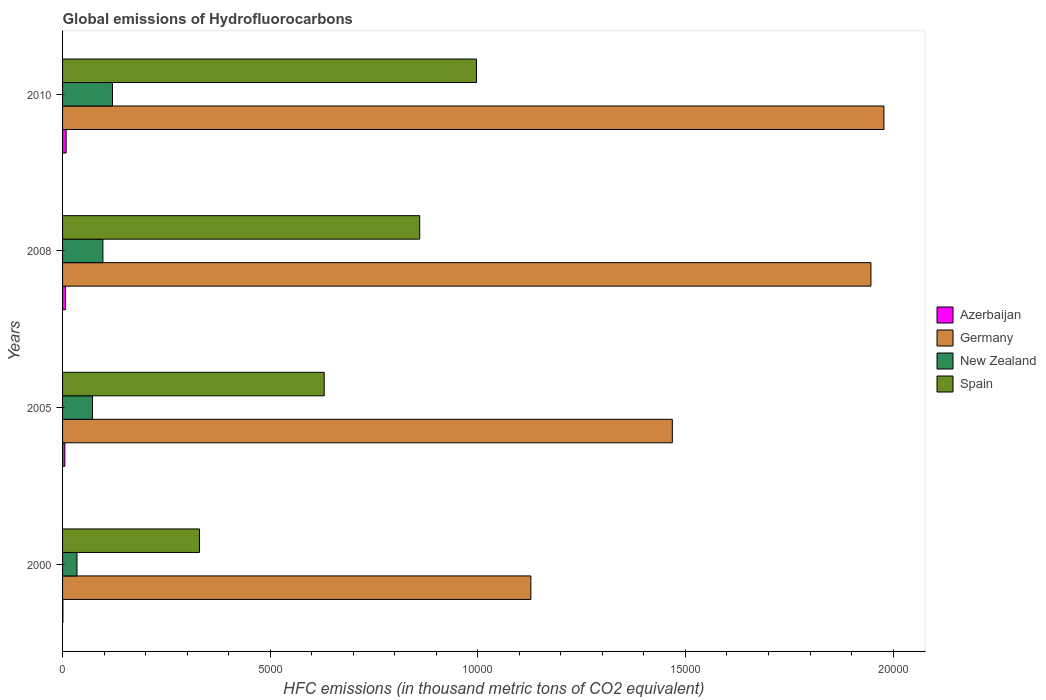How many groups of bars are there?
Your answer should be very brief. 4. What is the label of the 1st group of bars from the top?
Offer a terse response. 2010. What is the global emissions of Hydrofluorocarbons in New Zealand in 2005?
Ensure brevity in your answer.  721.7. Across all years, what is the maximum global emissions of Hydrofluorocarbons in Spain?
Make the answer very short. 9968. Across all years, what is the minimum global emissions of Hydrofluorocarbons in Spain?
Offer a terse response. 3296.8. In which year was the global emissions of Hydrofluorocarbons in New Zealand maximum?
Offer a very short reply. 2010. In which year was the global emissions of Hydrofluorocarbons in Spain minimum?
Provide a succinct answer. 2000. What is the total global emissions of Hydrofluorocarbons in Azerbaijan in the graph?
Ensure brevity in your answer.  223. What is the difference between the global emissions of Hydrofluorocarbons in New Zealand in 2005 and that in 2010?
Make the answer very short. -480.3. What is the difference between the global emissions of Hydrofluorocarbons in Germany in 2000 and the global emissions of Hydrofluorocarbons in New Zealand in 2008?
Offer a terse response. 1.03e+04. What is the average global emissions of Hydrofluorocarbons in Azerbaijan per year?
Provide a succinct answer. 55.75. In the year 2010, what is the difference between the global emissions of Hydrofluorocarbons in New Zealand and global emissions of Hydrofluorocarbons in Azerbaijan?
Give a very brief answer. 1116. What is the ratio of the global emissions of Hydrofluorocarbons in Azerbaijan in 2000 to that in 2005?
Make the answer very short. 0.15. What is the difference between the highest and the second highest global emissions of Hydrofluorocarbons in Spain?
Give a very brief answer. 1367.1. What is the difference between the highest and the lowest global emissions of Hydrofluorocarbons in New Zealand?
Your response must be concise. 854.7. Is the sum of the global emissions of Hydrofluorocarbons in Azerbaijan in 2000 and 2008 greater than the maximum global emissions of Hydrofluorocarbons in New Zealand across all years?
Your answer should be very brief. No. What does the 2nd bar from the top in 2000 represents?
Your response must be concise. New Zealand. What does the 3rd bar from the bottom in 2008 represents?
Keep it short and to the point. New Zealand. How many years are there in the graph?
Ensure brevity in your answer.  4. What is the difference between two consecutive major ticks on the X-axis?
Provide a short and direct response. 5000. Does the graph contain any zero values?
Your answer should be compact. No. Does the graph contain grids?
Keep it short and to the point. No. How many legend labels are there?
Offer a very short reply. 4. What is the title of the graph?
Your response must be concise. Global emissions of Hydrofluorocarbons. What is the label or title of the X-axis?
Keep it short and to the point. HFC emissions (in thousand metric tons of CO2 equivalent). What is the HFC emissions (in thousand metric tons of CO2 equivalent) in Azerbaijan in 2000?
Offer a very short reply. 8.5. What is the HFC emissions (in thousand metric tons of CO2 equivalent) in Germany in 2000?
Offer a terse response. 1.13e+04. What is the HFC emissions (in thousand metric tons of CO2 equivalent) in New Zealand in 2000?
Offer a very short reply. 347.3. What is the HFC emissions (in thousand metric tons of CO2 equivalent) of Spain in 2000?
Offer a very short reply. 3296.8. What is the HFC emissions (in thousand metric tons of CO2 equivalent) in Azerbaijan in 2005?
Give a very brief answer. 55.4. What is the HFC emissions (in thousand metric tons of CO2 equivalent) of Germany in 2005?
Make the answer very short. 1.47e+04. What is the HFC emissions (in thousand metric tons of CO2 equivalent) of New Zealand in 2005?
Provide a short and direct response. 721.7. What is the HFC emissions (in thousand metric tons of CO2 equivalent) of Spain in 2005?
Ensure brevity in your answer.  6300.3. What is the HFC emissions (in thousand metric tons of CO2 equivalent) of Azerbaijan in 2008?
Provide a short and direct response. 73.1. What is the HFC emissions (in thousand metric tons of CO2 equivalent) in Germany in 2008?
Give a very brief answer. 1.95e+04. What is the HFC emissions (in thousand metric tons of CO2 equivalent) of New Zealand in 2008?
Make the answer very short. 971.4. What is the HFC emissions (in thousand metric tons of CO2 equivalent) in Spain in 2008?
Your response must be concise. 8600.9. What is the HFC emissions (in thousand metric tons of CO2 equivalent) in Azerbaijan in 2010?
Keep it short and to the point. 86. What is the HFC emissions (in thousand metric tons of CO2 equivalent) in Germany in 2010?
Give a very brief answer. 1.98e+04. What is the HFC emissions (in thousand metric tons of CO2 equivalent) of New Zealand in 2010?
Keep it short and to the point. 1202. What is the HFC emissions (in thousand metric tons of CO2 equivalent) in Spain in 2010?
Provide a succinct answer. 9968. Across all years, what is the maximum HFC emissions (in thousand metric tons of CO2 equivalent) of Germany?
Give a very brief answer. 1.98e+04. Across all years, what is the maximum HFC emissions (in thousand metric tons of CO2 equivalent) in New Zealand?
Offer a very short reply. 1202. Across all years, what is the maximum HFC emissions (in thousand metric tons of CO2 equivalent) of Spain?
Keep it short and to the point. 9968. Across all years, what is the minimum HFC emissions (in thousand metric tons of CO2 equivalent) in Azerbaijan?
Offer a very short reply. 8.5. Across all years, what is the minimum HFC emissions (in thousand metric tons of CO2 equivalent) in Germany?
Offer a very short reply. 1.13e+04. Across all years, what is the minimum HFC emissions (in thousand metric tons of CO2 equivalent) of New Zealand?
Provide a succinct answer. 347.3. Across all years, what is the minimum HFC emissions (in thousand metric tons of CO2 equivalent) in Spain?
Give a very brief answer. 3296.8. What is the total HFC emissions (in thousand metric tons of CO2 equivalent) in Azerbaijan in the graph?
Offer a terse response. 223. What is the total HFC emissions (in thousand metric tons of CO2 equivalent) in Germany in the graph?
Make the answer very short. 6.52e+04. What is the total HFC emissions (in thousand metric tons of CO2 equivalent) of New Zealand in the graph?
Offer a terse response. 3242.4. What is the total HFC emissions (in thousand metric tons of CO2 equivalent) in Spain in the graph?
Provide a succinct answer. 2.82e+04. What is the difference between the HFC emissions (in thousand metric tons of CO2 equivalent) in Azerbaijan in 2000 and that in 2005?
Your answer should be very brief. -46.9. What is the difference between the HFC emissions (in thousand metric tons of CO2 equivalent) of Germany in 2000 and that in 2005?
Provide a succinct answer. -3407. What is the difference between the HFC emissions (in thousand metric tons of CO2 equivalent) of New Zealand in 2000 and that in 2005?
Your answer should be compact. -374.4. What is the difference between the HFC emissions (in thousand metric tons of CO2 equivalent) in Spain in 2000 and that in 2005?
Your answer should be compact. -3003.5. What is the difference between the HFC emissions (in thousand metric tons of CO2 equivalent) in Azerbaijan in 2000 and that in 2008?
Keep it short and to the point. -64.6. What is the difference between the HFC emissions (in thousand metric tons of CO2 equivalent) in Germany in 2000 and that in 2008?
Offer a very short reply. -8189.2. What is the difference between the HFC emissions (in thousand metric tons of CO2 equivalent) of New Zealand in 2000 and that in 2008?
Offer a terse response. -624.1. What is the difference between the HFC emissions (in thousand metric tons of CO2 equivalent) in Spain in 2000 and that in 2008?
Keep it short and to the point. -5304.1. What is the difference between the HFC emissions (in thousand metric tons of CO2 equivalent) in Azerbaijan in 2000 and that in 2010?
Provide a succinct answer. -77.5. What is the difference between the HFC emissions (in thousand metric tons of CO2 equivalent) in Germany in 2000 and that in 2010?
Your answer should be compact. -8502.4. What is the difference between the HFC emissions (in thousand metric tons of CO2 equivalent) in New Zealand in 2000 and that in 2010?
Provide a succinct answer. -854.7. What is the difference between the HFC emissions (in thousand metric tons of CO2 equivalent) in Spain in 2000 and that in 2010?
Provide a short and direct response. -6671.2. What is the difference between the HFC emissions (in thousand metric tons of CO2 equivalent) in Azerbaijan in 2005 and that in 2008?
Your answer should be very brief. -17.7. What is the difference between the HFC emissions (in thousand metric tons of CO2 equivalent) in Germany in 2005 and that in 2008?
Your answer should be compact. -4782.2. What is the difference between the HFC emissions (in thousand metric tons of CO2 equivalent) of New Zealand in 2005 and that in 2008?
Provide a short and direct response. -249.7. What is the difference between the HFC emissions (in thousand metric tons of CO2 equivalent) of Spain in 2005 and that in 2008?
Keep it short and to the point. -2300.6. What is the difference between the HFC emissions (in thousand metric tons of CO2 equivalent) in Azerbaijan in 2005 and that in 2010?
Ensure brevity in your answer.  -30.6. What is the difference between the HFC emissions (in thousand metric tons of CO2 equivalent) of Germany in 2005 and that in 2010?
Offer a terse response. -5095.4. What is the difference between the HFC emissions (in thousand metric tons of CO2 equivalent) of New Zealand in 2005 and that in 2010?
Offer a very short reply. -480.3. What is the difference between the HFC emissions (in thousand metric tons of CO2 equivalent) of Spain in 2005 and that in 2010?
Your response must be concise. -3667.7. What is the difference between the HFC emissions (in thousand metric tons of CO2 equivalent) of Germany in 2008 and that in 2010?
Offer a terse response. -313.2. What is the difference between the HFC emissions (in thousand metric tons of CO2 equivalent) in New Zealand in 2008 and that in 2010?
Provide a short and direct response. -230.6. What is the difference between the HFC emissions (in thousand metric tons of CO2 equivalent) of Spain in 2008 and that in 2010?
Make the answer very short. -1367.1. What is the difference between the HFC emissions (in thousand metric tons of CO2 equivalent) in Azerbaijan in 2000 and the HFC emissions (in thousand metric tons of CO2 equivalent) in Germany in 2005?
Keep it short and to the point. -1.47e+04. What is the difference between the HFC emissions (in thousand metric tons of CO2 equivalent) of Azerbaijan in 2000 and the HFC emissions (in thousand metric tons of CO2 equivalent) of New Zealand in 2005?
Keep it short and to the point. -713.2. What is the difference between the HFC emissions (in thousand metric tons of CO2 equivalent) in Azerbaijan in 2000 and the HFC emissions (in thousand metric tons of CO2 equivalent) in Spain in 2005?
Your answer should be very brief. -6291.8. What is the difference between the HFC emissions (in thousand metric tons of CO2 equivalent) of Germany in 2000 and the HFC emissions (in thousand metric tons of CO2 equivalent) of New Zealand in 2005?
Your response must be concise. 1.06e+04. What is the difference between the HFC emissions (in thousand metric tons of CO2 equivalent) in Germany in 2000 and the HFC emissions (in thousand metric tons of CO2 equivalent) in Spain in 2005?
Offer a terse response. 4977.3. What is the difference between the HFC emissions (in thousand metric tons of CO2 equivalent) of New Zealand in 2000 and the HFC emissions (in thousand metric tons of CO2 equivalent) of Spain in 2005?
Your answer should be very brief. -5953. What is the difference between the HFC emissions (in thousand metric tons of CO2 equivalent) of Azerbaijan in 2000 and the HFC emissions (in thousand metric tons of CO2 equivalent) of Germany in 2008?
Ensure brevity in your answer.  -1.95e+04. What is the difference between the HFC emissions (in thousand metric tons of CO2 equivalent) in Azerbaijan in 2000 and the HFC emissions (in thousand metric tons of CO2 equivalent) in New Zealand in 2008?
Ensure brevity in your answer.  -962.9. What is the difference between the HFC emissions (in thousand metric tons of CO2 equivalent) in Azerbaijan in 2000 and the HFC emissions (in thousand metric tons of CO2 equivalent) in Spain in 2008?
Your response must be concise. -8592.4. What is the difference between the HFC emissions (in thousand metric tons of CO2 equivalent) in Germany in 2000 and the HFC emissions (in thousand metric tons of CO2 equivalent) in New Zealand in 2008?
Offer a very short reply. 1.03e+04. What is the difference between the HFC emissions (in thousand metric tons of CO2 equivalent) of Germany in 2000 and the HFC emissions (in thousand metric tons of CO2 equivalent) of Spain in 2008?
Give a very brief answer. 2676.7. What is the difference between the HFC emissions (in thousand metric tons of CO2 equivalent) of New Zealand in 2000 and the HFC emissions (in thousand metric tons of CO2 equivalent) of Spain in 2008?
Ensure brevity in your answer.  -8253.6. What is the difference between the HFC emissions (in thousand metric tons of CO2 equivalent) in Azerbaijan in 2000 and the HFC emissions (in thousand metric tons of CO2 equivalent) in Germany in 2010?
Ensure brevity in your answer.  -1.98e+04. What is the difference between the HFC emissions (in thousand metric tons of CO2 equivalent) in Azerbaijan in 2000 and the HFC emissions (in thousand metric tons of CO2 equivalent) in New Zealand in 2010?
Ensure brevity in your answer.  -1193.5. What is the difference between the HFC emissions (in thousand metric tons of CO2 equivalent) in Azerbaijan in 2000 and the HFC emissions (in thousand metric tons of CO2 equivalent) in Spain in 2010?
Offer a terse response. -9959.5. What is the difference between the HFC emissions (in thousand metric tons of CO2 equivalent) in Germany in 2000 and the HFC emissions (in thousand metric tons of CO2 equivalent) in New Zealand in 2010?
Provide a succinct answer. 1.01e+04. What is the difference between the HFC emissions (in thousand metric tons of CO2 equivalent) in Germany in 2000 and the HFC emissions (in thousand metric tons of CO2 equivalent) in Spain in 2010?
Provide a short and direct response. 1309.6. What is the difference between the HFC emissions (in thousand metric tons of CO2 equivalent) in New Zealand in 2000 and the HFC emissions (in thousand metric tons of CO2 equivalent) in Spain in 2010?
Offer a very short reply. -9620.7. What is the difference between the HFC emissions (in thousand metric tons of CO2 equivalent) in Azerbaijan in 2005 and the HFC emissions (in thousand metric tons of CO2 equivalent) in Germany in 2008?
Give a very brief answer. -1.94e+04. What is the difference between the HFC emissions (in thousand metric tons of CO2 equivalent) of Azerbaijan in 2005 and the HFC emissions (in thousand metric tons of CO2 equivalent) of New Zealand in 2008?
Keep it short and to the point. -916. What is the difference between the HFC emissions (in thousand metric tons of CO2 equivalent) of Azerbaijan in 2005 and the HFC emissions (in thousand metric tons of CO2 equivalent) of Spain in 2008?
Your answer should be compact. -8545.5. What is the difference between the HFC emissions (in thousand metric tons of CO2 equivalent) in Germany in 2005 and the HFC emissions (in thousand metric tons of CO2 equivalent) in New Zealand in 2008?
Offer a terse response. 1.37e+04. What is the difference between the HFC emissions (in thousand metric tons of CO2 equivalent) of Germany in 2005 and the HFC emissions (in thousand metric tons of CO2 equivalent) of Spain in 2008?
Offer a terse response. 6083.7. What is the difference between the HFC emissions (in thousand metric tons of CO2 equivalent) in New Zealand in 2005 and the HFC emissions (in thousand metric tons of CO2 equivalent) in Spain in 2008?
Make the answer very short. -7879.2. What is the difference between the HFC emissions (in thousand metric tons of CO2 equivalent) in Azerbaijan in 2005 and the HFC emissions (in thousand metric tons of CO2 equivalent) in Germany in 2010?
Give a very brief answer. -1.97e+04. What is the difference between the HFC emissions (in thousand metric tons of CO2 equivalent) of Azerbaijan in 2005 and the HFC emissions (in thousand metric tons of CO2 equivalent) of New Zealand in 2010?
Give a very brief answer. -1146.6. What is the difference between the HFC emissions (in thousand metric tons of CO2 equivalent) in Azerbaijan in 2005 and the HFC emissions (in thousand metric tons of CO2 equivalent) in Spain in 2010?
Make the answer very short. -9912.6. What is the difference between the HFC emissions (in thousand metric tons of CO2 equivalent) of Germany in 2005 and the HFC emissions (in thousand metric tons of CO2 equivalent) of New Zealand in 2010?
Offer a very short reply. 1.35e+04. What is the difference between the HFC emissions (in thousand metric tons of CO2 equivalent) in Germany in 2005 and the HFC emissions (in thousand metric tons of CO2 equivalent) in Spain in 2010?
Your answer should be very brief. 4716.6. What is the difference between the HFC emissions (in thousand metric tons of CO2 equivalent) of New Zealand in 2005 and the HFC emissions (in thousand metric tons of CO2 equivalent) of Spain in 2010?
Offer a very short reply. -9246.3. What is the difference between the HFC emissions (in thousand metric tons of CO2 equivalent) in Azerbaijan in 2008 and the HFC emissions (in thousand metric tons of CO2 equivalent) in Germany in 2010?
Keep it short and to the point. -1.97e+04. What is the difference between the HFC emissions (in thousand metric tons of CO2 equivalent) of Azerbaijan in 2008 and the HFC emissions (in thousand metric tons of CO2 equivalent) of New Zealand in 2010?
Offer a very short reply. -1128.9. What is the difference between the HFC emissions (in thousand metric tons of CO2 equivalent) of Azerbaijan in 2008 and the HFC emissions (in thousand metric tons of CO2 equivalent) of Spain in 2010?
Give a very brief answer. -9894.9. What is the difference between the HFC emissions (in thousand metric tons of CO2 equivalent) in Germany in 2008 and the HFC emissions (in thousand metric tons of CO2 equivalent) in New Zealand in 2010?
Your answer should be very brief. 1.83e+04. What is the difference between the HFC emissions (in thousand metric tons of CO2 equivalent) in Germany in 2008 and the HFC emissions (in thousand metric tons of CO2 equivalent) in Spain in 2010?
Give a very brief answer. 9498.8. What is the difference between the HFC emissions (in thousand metric tons of CO2 equivalent) in New Zealand in 2008 and the HFC emissions (in thousand metric tons of CO2 equivalent) in Spain in 2010?
Keep it short and to the point. -8996.6. What is the average HFC emissions (in thousand metric tons of CO2 equivalent) in Azerbaijan per year?
Keep it short and to the point. 55.75. What is the average HFC emissions (in thousand metric tons of CO2 equivalent) in Germany per year?
Your answer should be compact. 1.63e+04. What is the average HFC emissions (in thousand metric tons of CO2 equivalent) of New Zealand per year?
Your response must be concise. 810.6. What is the average HFC emissions (in thousand metric tons of CO2 equivalent) in Spain per year?
Offer a very short reply. 7041.5. In the year 2000, what is the difference between the HFC emissions (in thousand metric tons of CO2 equivalent) in Azerbaijan and HFC emissions (in thousand metric tons of CO2 equivalent) in Germany?
Keep it short and to the point. -1.13e+04. In the year 2000, what is the difference between the HFC emissions (in thousand metric tons of CO2 equivalent) of Azerbaijan and HFC emissions (in thousand metric tons of CO2 equivalent) of New Zealand?
Provide a succinct answer. -338.8. In the year 2000, what is the difference between the HFC emissions (in thousand metric tons of CO2 equivalent) of Azerbaijan and HFC emissions (in thousand metric tons of CO2 equivalent) of Spain?
Your answer should be compact. -3288.3. In the year 2000, what is the difference between the HFC emissions (in thousand metric tons of CO2 equivalent) in Germany and HFC emissions (in thousand metric tons of CO2 equivalent) in New Zealand?
Provide a succinct answer. 1.09e+04. In the year 2000, what is the difference between the HFC emissions (in thousand metric tons of CO2 equivalent) of Germany and HFC emissions (in thousand metric tons of CO2 equivalent) of Spain?
Keep it short and to the point. 7980.8. In the year 2000, what is the difference between the HFC emissions (in thousand metric tons of CO2 equivalent) in New Zealand and HFC emissions (in thousand metric tons of CO2 equivalent) in Spain?
Keep it short and to the point. -2949.5. In the year 2005, what is the difference between the HFC emissions (in thousand metric tons of CO2 equivalent) in Azerbaijan and HFC emissions (in thousand metric tons of CO2 equivalent) in Germany?
Give a very brief answer. -1.46e+04. In the year 2005, what is the difference between the HFC emissions (in thousand metric tons of CO2 equivalent) of Azerbaijan and HFC emissions (in thousand metric tons of CO2 equivalent) of New Zealand?
Provide a succinct answer. -666.3. In the year 2005, what is the difference between the HFC emissions (in thousand metric tons of CO2 equivalent) of Azerbaijan and HFC emissions (in thousand metric tons of CO2 equivalent) of Spain?
Offer a very short reply. -6244.9. In the year 2005, what is the difference between the HFC emissions (in thousand metric tons of CO2 equivalent) in Germany and HFC emissions (in thousand metric tons of CO2 equivalent) in New Zealand?
Give a very brief answer. 1.40e+04. In the year 2005, what is the difference between the HFC emissions (in thousand metric tons of CO2 equivalent) in Germany and HFC emissions (in thousand metric tons of CO2 equivalent) in Spain?
Give a very brief answer. 8384.3. In the year 2005, what is the difference between the HFC emissions (in thousand metric tons of CO2 equivalent) of New Zealand and HFC emissions (in thousand metric tons of CO2 equivalent) of Spain?
Make the answer very short. -5578.6. In the year 2008, what is the difference between the HFC emissions (in thousand metric tons of CO2 equivalent) in Azerbaijan and HFC emissions (in thousand metric tons of CO2 equivalent) in Germany?
Your answer should be very brief. -1.94e+04. In the year 2008, what is the difference between the HFC emissions (in thousand metric tons of CO2 equivalent) in Azerbaijan and HFC emissions (in thousand metric tons of CO2 equivalent) in New Zealand?
Give a very brief answer. -898.3. In the year 2008, what is the difference between the HFC emissions (in thousand metric tons of CO2 equivalent) of Azerbaijan and HFC emissions (in thousand metric tons of CO2 equivalent) of Spain?
Provide a short and direct response. -8527.8. In the year 2008, what is the difference between the HFC emissions (in thousand metric tons of CO2 equivalent) in Germany and HFC emissions (in thousand metric tons of CO2 equivalent) in New Zealand?
Your answer should be very brief. 1.85e+04. In the year 2008, what is the difference between the HFC emissions (in thousand metric tons of CO2 equivalent) of Germany and HFC emissions (in thousand metric tons of CO2 equivalent) of Spain?
Make the answer very short. 1.09e+04. In the year 2008, what is the difference between the HFC emissions (in thousand metric tons of CO2 equivalent) in New Zealand and HFC emissions (in thousand metric tons of CO2 equivalent) in Spain?
Give a very brief answer. -7629.5. In the year 2010, what is the difference between the HFC emissions (in thousand metric tons of CO2 equivalent) in Azerbaijan and HFC emissions (in thousand metric tons of CO2 equivalent) in Germany?
Your response must be concise. -1.97e+04. In the year 2010, what is the difference between the HFC emissions (in thousand metric tons of CO2 equivalent) in Azerbaijan and HFC emissions (in thousand metric tons of CO2 equivalent) in New Zealand?
Give a very brief answer. -1116. In the year 2010, what is the difference between the HFC emissions (in thousand metric tons of CO2 equivalent) in Azerbaijan and HFC emissions (in thousand metric tons of CO2 equivalent) in Spain?
Make the answer very short. -9882. In the year 2010, what is the difference between the HFC emissions (in thousand metric tons of CO2 equivalent) of Germany and HFC emissions (in thousand metric tons of CO2 equivalent) of New Zealand?
Offer a very short reply. 1.86e+04. In the year 2010, what is the difference between the HFC emissions (in thousand metric tons of CO2 equivalent) in Germany and HFC emissions (in thousand metric tons of CO2 equivalent) in Spain?
Provide a succinct answer. 9812. In the year 2010, what is the difference between the HFC emissions (in thousand metric tons of CO2 equivalent) of New Zealand and HFC emissions (in thousand metric tons of CO2 equivalent) of Spain?
Offer a very short reply. -8766. What is the ratio of the HFC emissions (in thousand metric tons of CO2 equivalent) of Azerbaijan in 2000 to that in 2005?
Ensure brevity in your answer.  0.15. What is the ratio of the HFC emissions (in thousand metric tons of CO2 equivalent) in Germany in 2000 to that in 2005?
Offer a terse response. 0.77. What is the ratio of the HFC emissions (in thousand metric tons of CO2 equivalent) of New Zealand in 2000 to that in 2005?
Ensure brevity in your answer.  0.48. What is the ratio of the HFC emissions (in thousand metric tons of CO2 equivalent) of Spain in 2000 to that in 2005?
Offer a terse response. 0.52. What is the ratio of the HFC emissions (in thousand metric tons of CO2 equivalent) in Azerbaijan in 2000 to that in 2008?
Provide a succinct answer. 0.12. What is the ratio of the HFC emissions (in thousand metric tons of CO2 equivalent) of Germany in 2000 to that in 2008?
Make the answer very short. 0.58. What is the ratio of the HFC emissions (in thousand metric tons of CO2 equivalent) of New Zealand in 2000 to that in 2008?
Provide a short and direct response. 0.36. What is the ratio of the HFC emissions (in thousand metric tons of CO2 equivalent) in Spain in 2000 to that in 2008?
Provide a succinct answer. 0.38. What is the ratio of the HFC emissions (in thousand metric tons of CO2 equivalent) in Azerbaijan in 2000 to that in 2010?
Your response must be concise. 0.1. What is the ratio of the HFC emissions (in thousand metric tons of CO2 equivalent) in Germany in 2000 to that in 2010?
Provide a short and direct response. 0.57. What is the ratio of the HFC emissions (in thousand metric tons of CO2 equivalent) of New Zealand in 2000 to that in 2010?
Offer a very short reply. 0.29. What is the ratio of the HFC emissions (in thousand metric tons of CO2 equivalent) in Spain in 2000 to that in 2010?
Your answer should be very brief. 0.33. What is the ratio of the HFC emissions (in thousand metric tons of CO2 equivalent) of Azerbaijan in 2005 to that in 2008?
Keep it short and to the point. 0.76. What is the ratio of the HFC emissions (in thousand metric tons of CO2 equivalent) in Germany in 2005 to that in 2008?
Provide a short and direct response. 0.75. What is the ratio of the HFC emissions (in thousand metric tons of CO2 equivalent) of New Zealand in 2005 to that in 2008?
Your answer should be very brief. 0.74. What is the ratio of the HFC emissions (in thousand metric tons of CO2 equivalent) of Spain in 2005 to that in 2008?
Provide a succinct answer. 0.73. What is the ratio of the HFC emissions (in thousand metric tons of CO2 equivalent) of Azerbaijan in 2005 to that in 2010?
Offer a terse response. 0.64. What is the ratio of the HFC emissions (in thousand metric tons of CO2 equivalent) of Germany in 2005 to that in 2010?
Provide a short and direct response. 0.74. What is the ratio of the HFC emissions (in thousand metric tons of CO2 equivalent) in New Zealand in 2005 to that in 2010?
Your answer should be compact. 0.6. What is the ratio of the HFC emissions (in thousand metric tons of CO2 equivalent) of Spain in 2005 to that in 2010?
Offer a very short reply. 0.63. What is the ratio of the HFC emissions (in thousand metric tons of CO2 equivalent) of Germany in 2008 to that in 2010?
Your answer should be compact. 0.98. What is the ratio of the HFC emissions (in thousand metric tons of CO2 equivalent) in New Zealand in 2008 to that in 2010?
Offer a very short reply. 0.81. What is the ratio of the HFC emissions (in thousand metric tons of CO2 equivalent) in Spain in 2008 to that in 2010?
Your answer should be very brief. 0.86. What is the difference between the highest and the second highest HFC emissions (in thousand metric tons of CO2 equivalent) in Germany?
Make the answer very short. 313.2. What is the difference between the highest and the second highest HFC emissions (in thousand metric tons of CO2 equivalent) in New Zealand?
Keep it short and to the point. 230.6. What is the difference between the highest and the second highest HFC emissions (in thousand metric tons of CO2 equivalent) in Spain?
Your answer should be very brief. 1367.1. What is the difference between the highest and the lowest HFC emissions (in thousand metric tons of CO2 equivalent) of Azerbaijan?
Provide a succinct answer. 77.5. What is the difference between the highest and the lowest HFC emissions (in thousand metric tons of CO2 equivalent) of Germany?
Ensure brevity in your answer.  8502.4. What is the difference between the highest and the lowest HFC emissions (in thousand metric tons of CO2 equivalent) of New Zealand?
Offer a very short reply. 854.7. What is the difference between the highest and the lowest HFC emissions (in thousand metric tons of CO2 equivalent) in Spain?
Your answer should be very brief. 6671.2. 